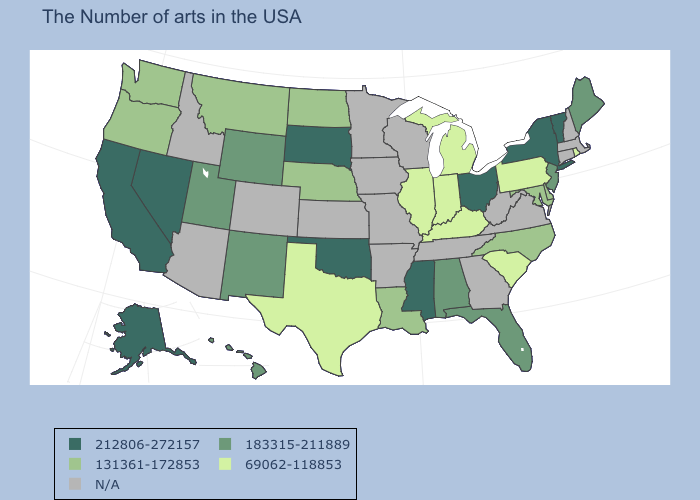Does Ohio have the highest value in the MidWest?
Give a very brief answer. Yes. Does Vermont have the highest value in the Northeast?
Keep it brief. Yes. Name the states that have a value in the range 183315-211889?
Give a very brief answer. Maine, New Jersey, Florida, Alabama, Wyoming, New Mexico, Utah, Hawaii. Does Utah have the highest value in the West?
Answer briefly. No. Which states hav the highest value in the Northeast?
Keep it brief. Vermont, New York. What is the value of Michigan?
Quick response, please. 69062-118853. Does Pennsylvania have the lowest value in the Northeast?
Keep it brief. Yes. What is the highest value in states that border Indiana?
Give a very brief answer. 212806-272157. Is the legend a continuous bar?
Give a very brief answer. No. What is the lowest value in the USA?
Keep it brief. 69062-118853. What is the value of Virginia?
Write a very short answer. N/A. Name the states that have a value in the range 212806-272157?
Quick response, please. Vermont, New York, Ohio, Mississippi, Oklahoma, South Dakota, Nevada, California, Alaska. What is the value of Connecticut?
Keep it brief. N/A. Which states hav the highest value in the West?
Short answer required. Nevada, California, Alaska. 